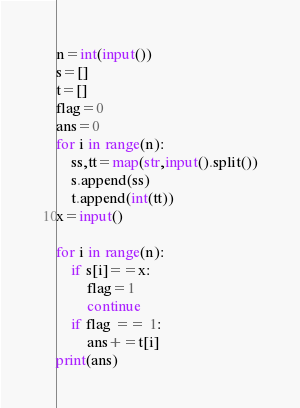Convert code to text. <code><loc_0><loc_0><loc_500><loc_500><_Python_>n=int(input())
s=[]
t=[]
flag=0
ans=0
for i in range(n):
    ss,tt=map(str,input().split())
    s.append(ss)
    t.append(int(tt))
x=input()

for i in range(n):
    if s[i]==x:
        flag=1
        continue
    if flag == 1:
        ans+=t[i]
print(ans)</code> 